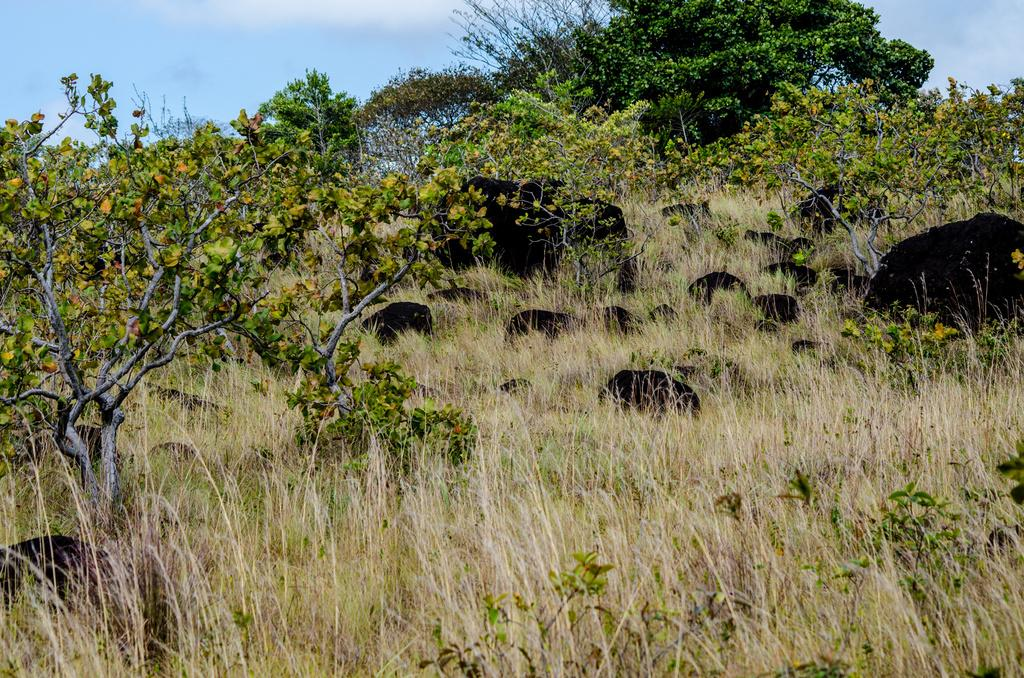What type of environment is depicted in the image? The image consists of a forest. What can be seen at the bottom of the image? There is grass at the bottom of the image. What is visible in the background of the image? There are trees in the background of the image. What objects are located in the middle of the image? There are rocks in the middle of the image. What is visible at the top of the image? The sky is visible at the top of the image. What type of game is being played on the sofa in the image? There is no sofa or game present in the image; it depicts a forest scene with grass, trees, rocks, and sky. 